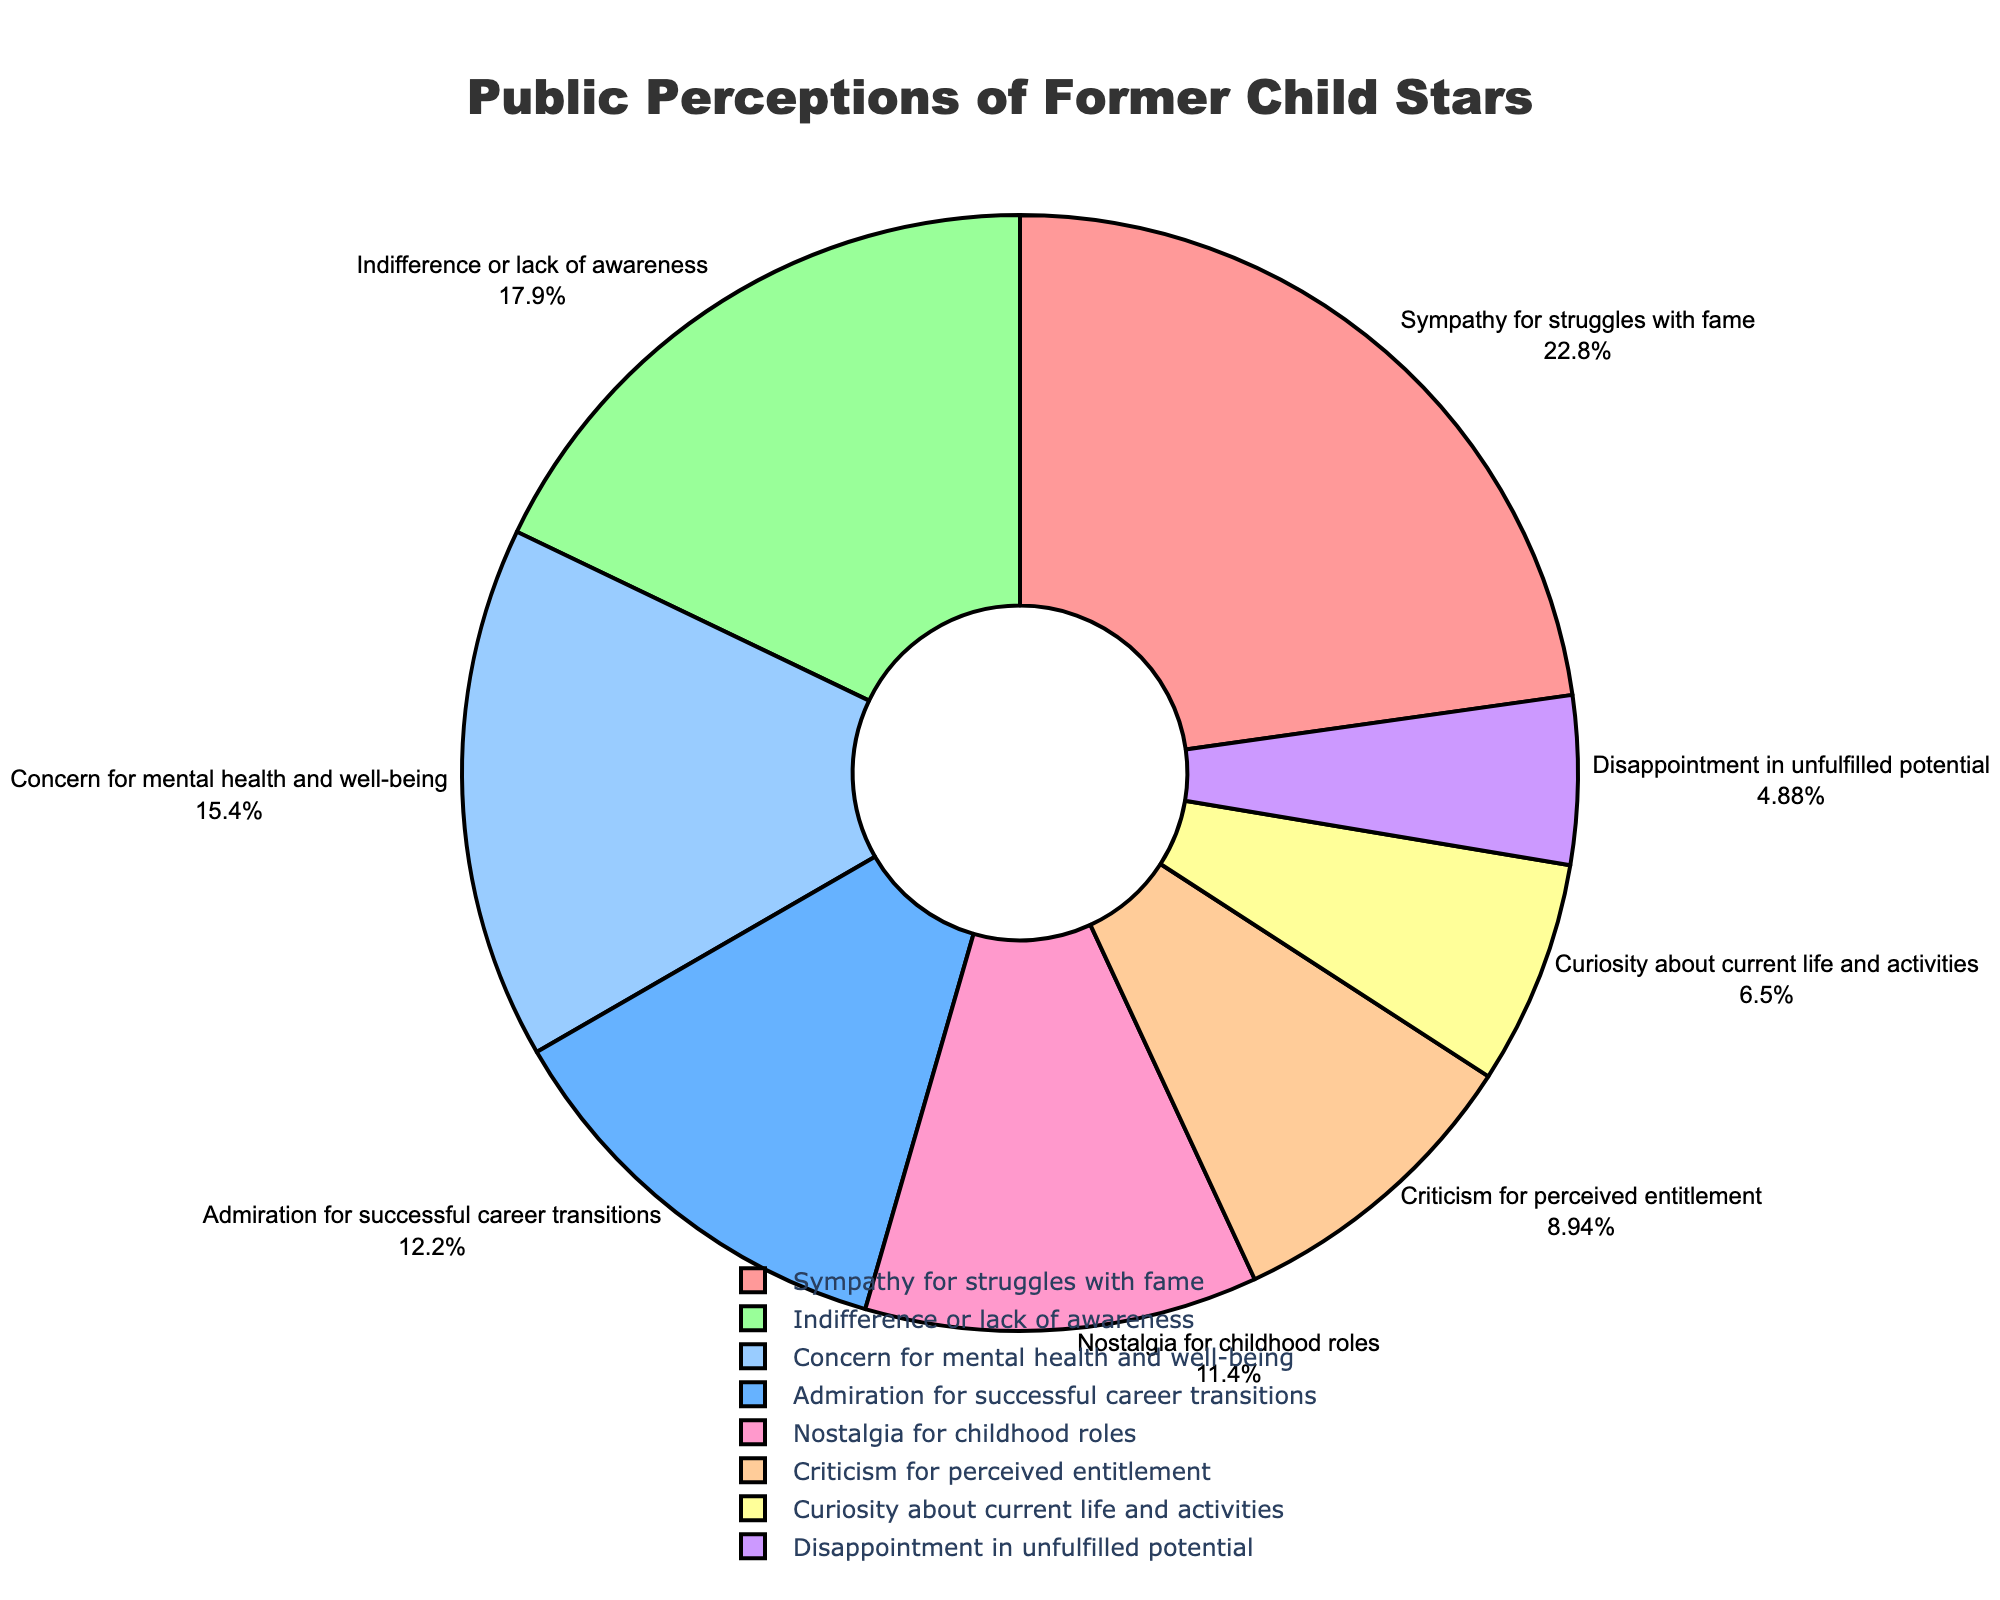What's the most common public perception of former child stars? Identify the segment of the pie chart with the largest percentage value. "Sympathy for struggles with fame" has the largest percentage at 28%.
Answer: Sympathy for struggles with fame How do admiration for successful career transitions and nostalgia for childhood roles compare? Compare the percentage values for both segments. Admiration for successful career transitions is 15%, and nostalgia for childhood roles is 14%. Thus, admiration for successful career transitions is higher by 1 percentage point.
Answer: Admiration for successful career transitions is higher What's the total percentage of people who either show indifference or criticize former child stars for perceived entitlement? Add the percentages for indifference or lack of awareness (22%) and criticism for perceived entitlement (11%). 22% + 11% equals 33%.
Answer: 33% Which perception is represented with concern for mental health and well-being, and what color is it? Identify the corresponding label and look at its color on the pie chart. Concern for mental health and well-being is 19% and is colored in a shade of blue.
Answer: Concern for mental health and well-being, blue What's the difference between the percentage of people who express disappointment in unfulfilled potential and those who show curiosity about current life and activities? Subtract the smaller percentage from the larger one. Curiosity about current life and activities is 8%, while disappointment in unfulfilled potential is 6%. 8% - 6% equals 2%.
Answer: 2% Is concern for mental health and well-being more common than nostalgia for childhood roles? Compare the percentages of these two segments. Concern for mental health and well-being is 19%, while nostalgia for childhood roles is 14%. Thus, concern for mental health and well-being is more common.
Answer: Yes What percentage of people admire former child stars for successful career transitions? Directly refer to the percentage value shown in the pie chart for this segment. Admiration for successful career transitions is 15%.
Answer: 15% Which perception has the lowest representation, and what is its percentage? Identify the segment with the smallest percentage value in the pie chart. Disappointment in unfulfilled potential has the lowest representation at 6%.
Answer: Disappointment in unfulfilled potential, 6% Can you calculate the combined percentage for positive perceptions (sympathy, admiration, and nostalgia)? Sum the percentages for sympathy for struggles with fame (28%), admiration for successful career transitions (15%), and nostalgia for childhood roles (14%). 28% + 15% + 14% equals 57%.
Answer: 57% Is public perception more positive or negative towards former child stars? Sum the positive perceptions (sympathy, admiration, and nostalgia) and compare them to the negative perceptions (criticism and disappointment). Positive: 28%+15%+14%=57%, Negative: 11%+6%=17%. Positive perceptions are higher.
Answer: Positive 